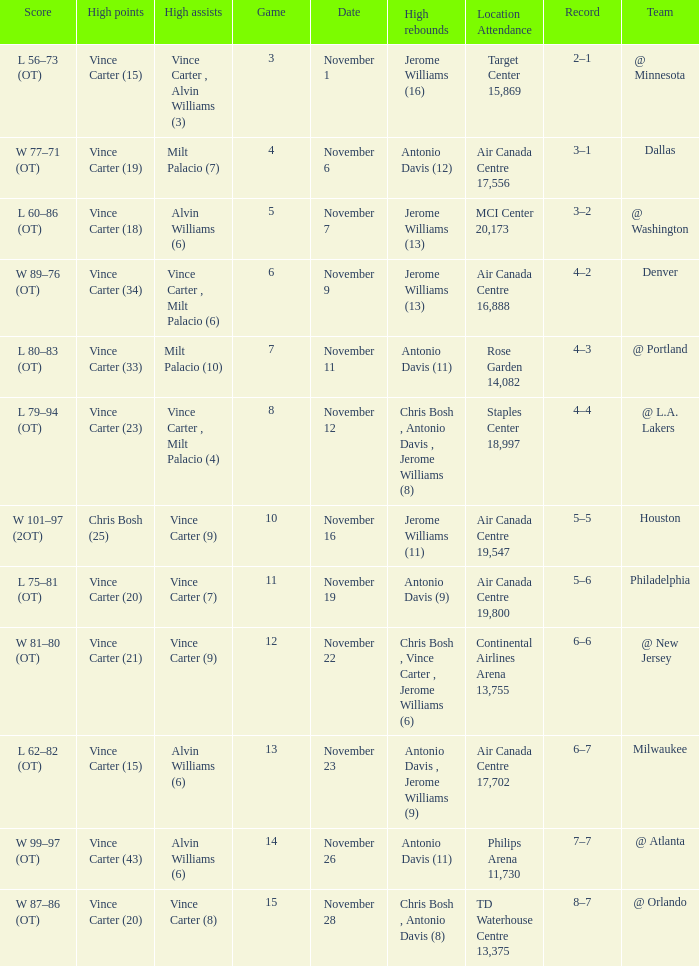On what date was the attendance at Continental Airlines Arena 13,755? November 22. 